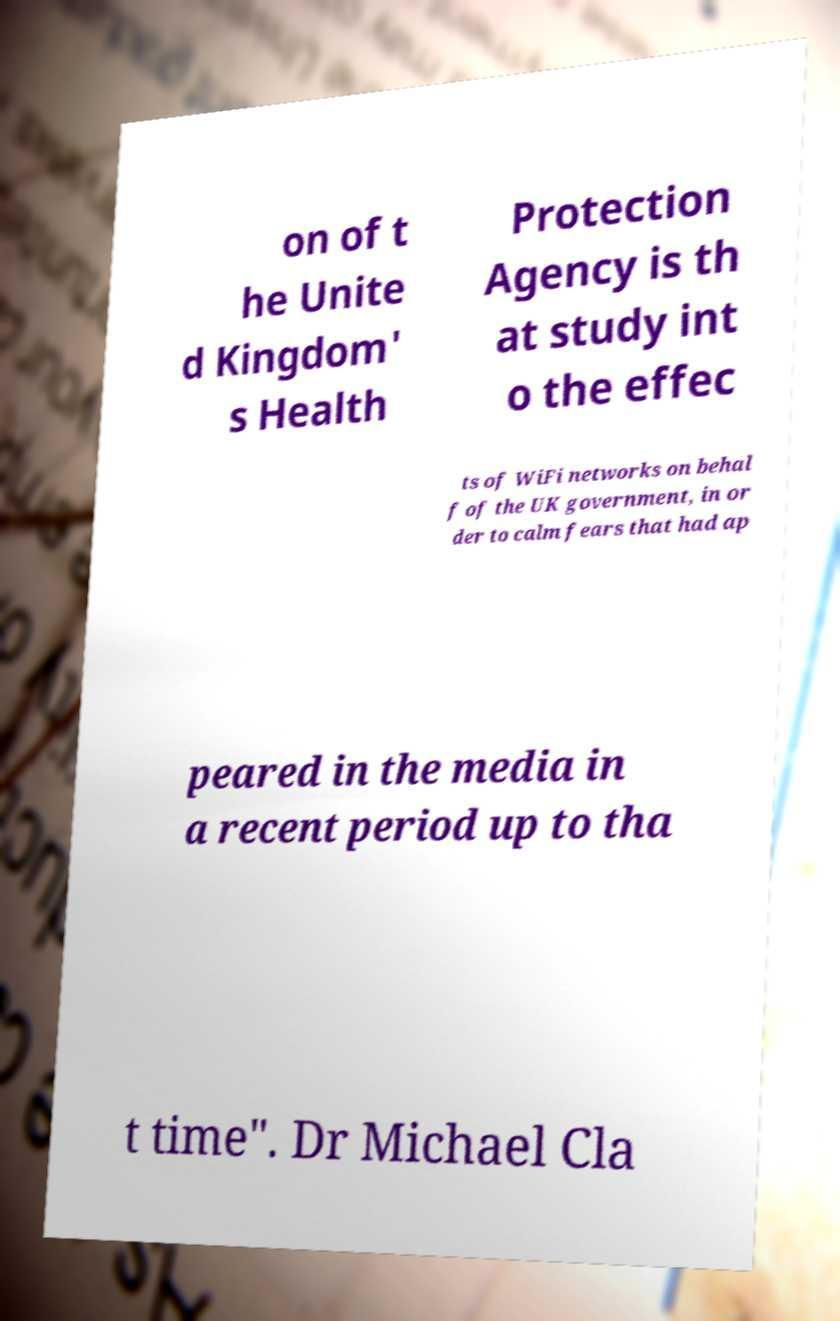Can you accurately transcribe the text from the provided image for me? on of t he Unite d Kingdom' s Health Protection Agency is th at study int o the effec ts of WiFi networks on behal f of the UK government, in or der to calm fears that had ap peared in the media in a recent period up to tha t time". Dr Michael Cla 